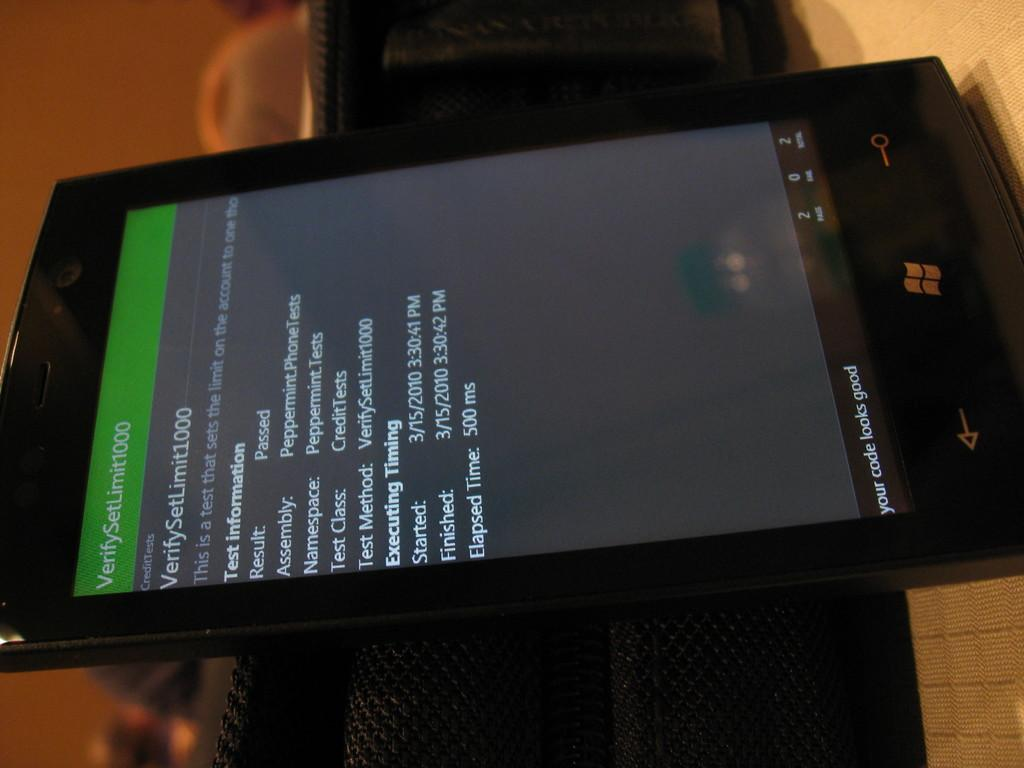<image>
Create a compact narrative representing the image presented. a tablet with the word Your Code Looks Good on it 